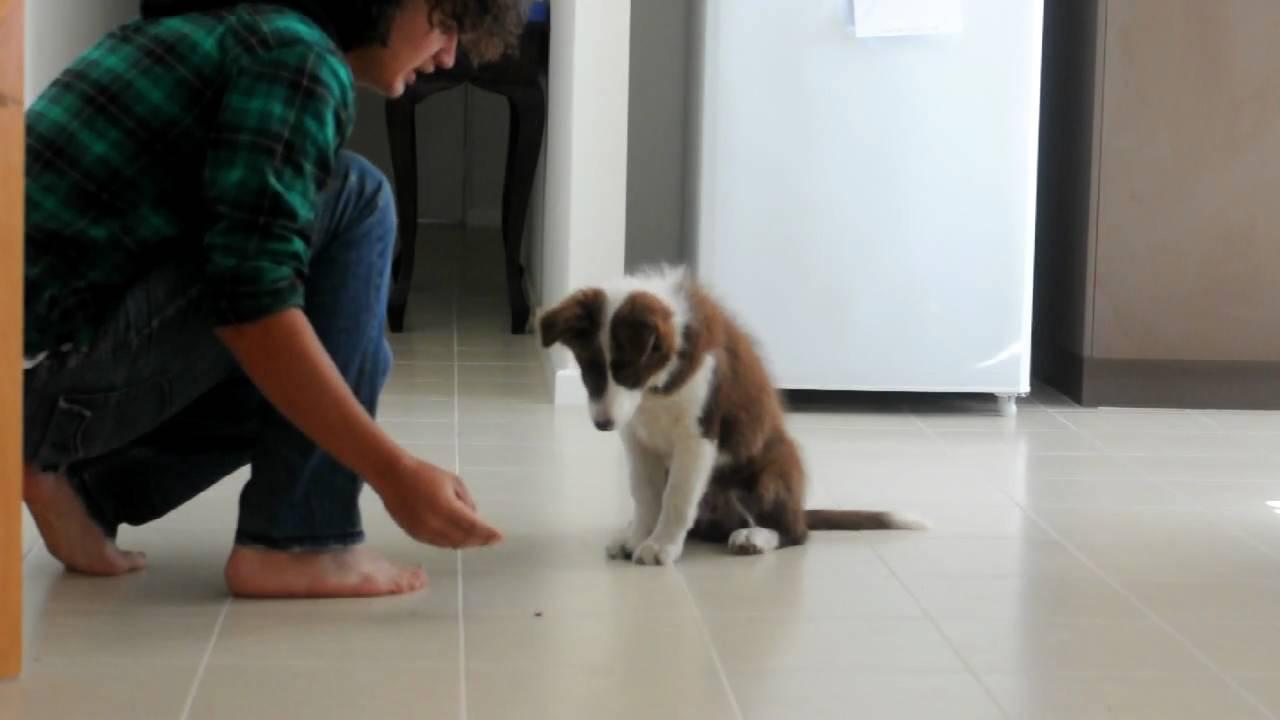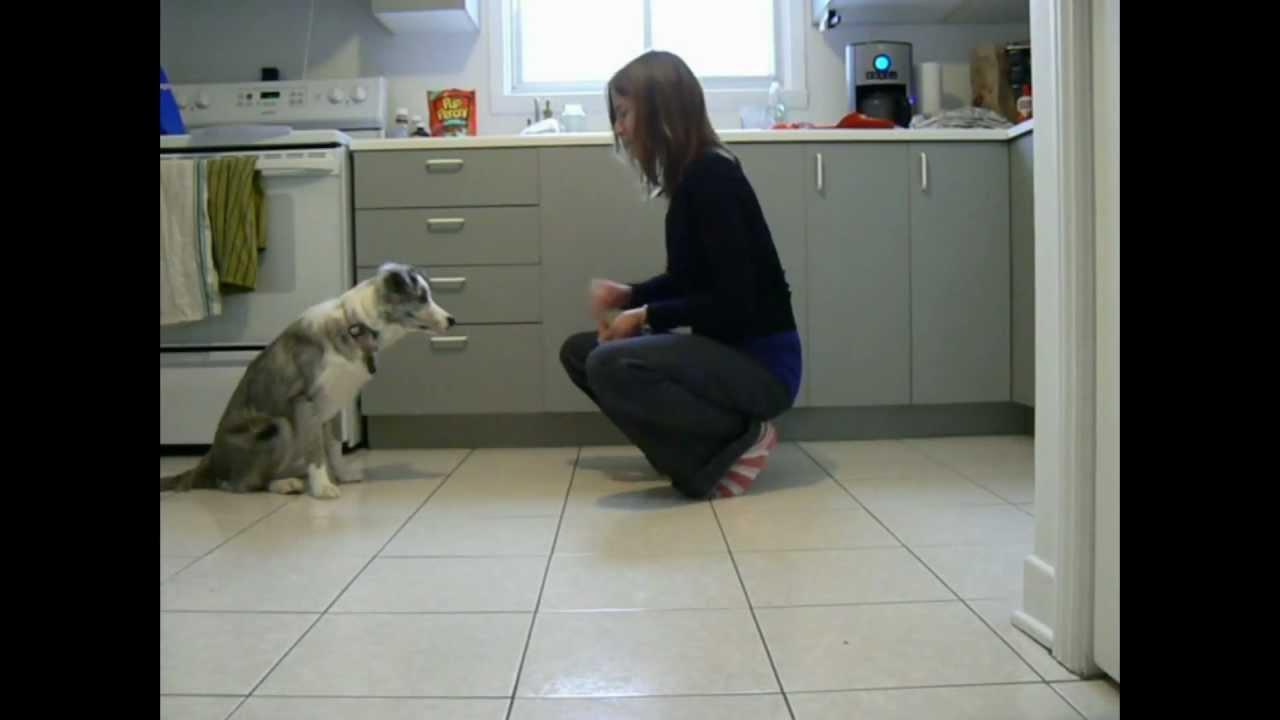The first image is the image on the left, the second image is the image on the right. For the images displayed, is the sentence "In one of the images there is a black and white dog lying on the floor." factually correct? Answer yes or no. No. The first image is the image on the left, the second image is the image on the right. Assess this claim about the two images: "At least one image includes a person in jeans next to a dog, and each image includes a dog that is sitting.". Correct or not? Answer yes or no. Yes. 